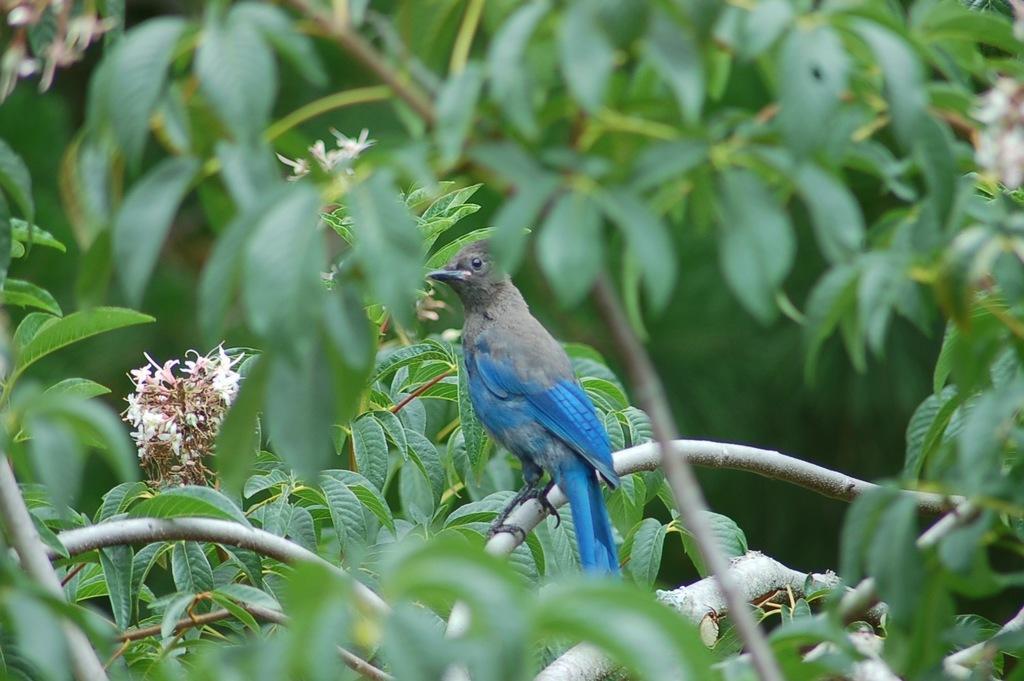Please provide a concise description of this image. In the picture I can see a bird is sitting on a branch of a plant. In the background I can see flower plants, these flowers are white in color. 